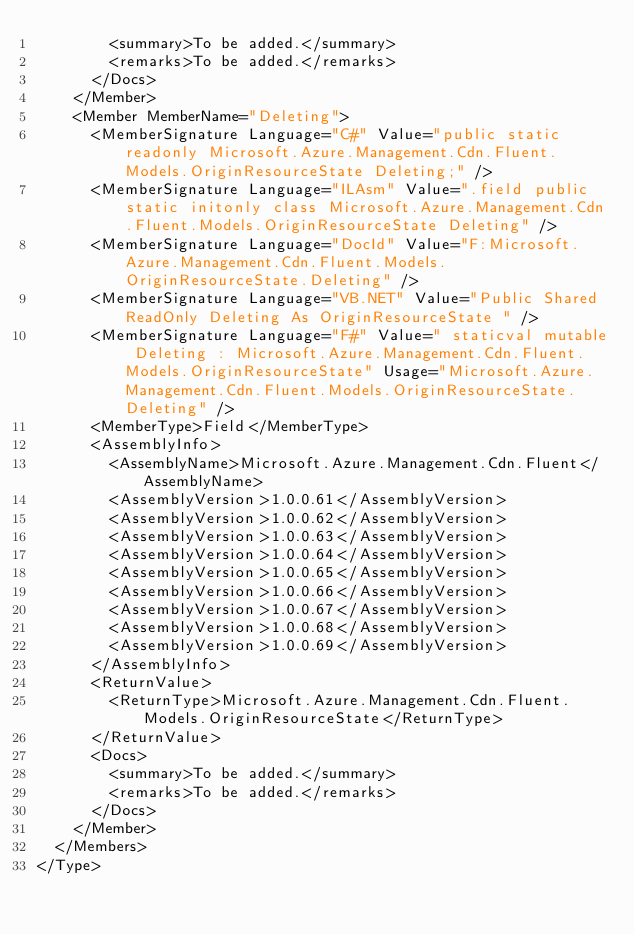<code> <loc_0><loc_0><loc_500><loc_500><_XML_>        <summary>To be added.</summary>
        <remarks>To be added.</remarks>
      </Docs>
    </Member>
    <Member MemberName="Deleting">
      <MemberSignature Language="C#" Value="public static readonly Microsoft.Azure.Management.Cdn.Fluent.Models.OriginResourceState Deleting;" />
      <MemberSignature Language="ILAsm" Value=".field public static initonly class Microsoft.Azure.Management.Cdn.Fluent.Models.OriginResourceState Deleting" />
      <MemberSignature Language="DocId" Value="F:Microsoft.Azure.Management.Cdn.Fluent.Models.OriginResourceState.Deleting" />
      <MemberSignature Language="VB.NET" Value="Public Shared ReadOnly Deleting As OriginResourceState " />
      <MemberSignature Language="F#" Value=" staticval mutable Deleting : Microsoft.Azure.Management.Cdn.Fluent.Models.OriginResourceState" Usage="Microsoft.Azure.Management.Cdn.Fluent.Models.OriginResourceState.Deleting" />
      <MemberType>Field</MemberType>
      <AssemblyInfo>
        <AssemblyName>Microsoft.Azure.Management.Cdn.Fluent</AssemblyName>
        <AssemblyVersion>1.0.0.61</AssemblyVersion>
        <AssemblyVersion>1.0.0.62</AssemblyVersion>
        <AssemblyVersion>1.0.0.63</AssemblyVersion>
        <AssemblyVersion>1.0.0.64</AssemblyVersion>
        <AssemblyVersion>1.0.0.65</AssemblyVersion>
        <AssemblyVersion>1.0.0.66</AssemblyVersion>
        <AssemblyVersion>1.0.0.67</AssemblyVersion>
        <AssemblyVersion>1.0.0.68</AssemblyVersion>
        <AssemblyVersion>1.0.0.69</AssemblyVersion>
      </AssemblyInfo>
      <ReturnValue>
        <ReturnType>Microsoft.Azure.Management.Cdn.Fluent.Models.OriginResourceState</ReturnType>
      </ReturnValue>
      <Docs>
        <summary>To be added.</summary>
        <remarks>To be added.</remarks>
      </Docs>
    </Member>
  </Members>
</Type>
</code> 